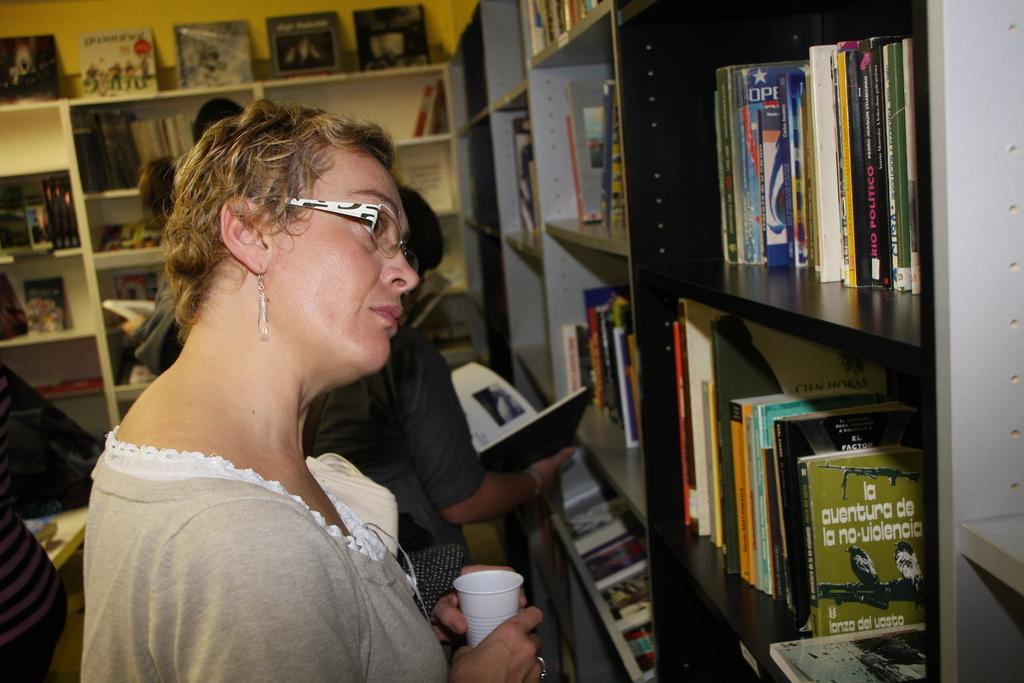<image>
Provide a brief description of the given image. A woman has her head tilted to read from the bookshelf with many boocks including the green one that starts with "la aventura." 